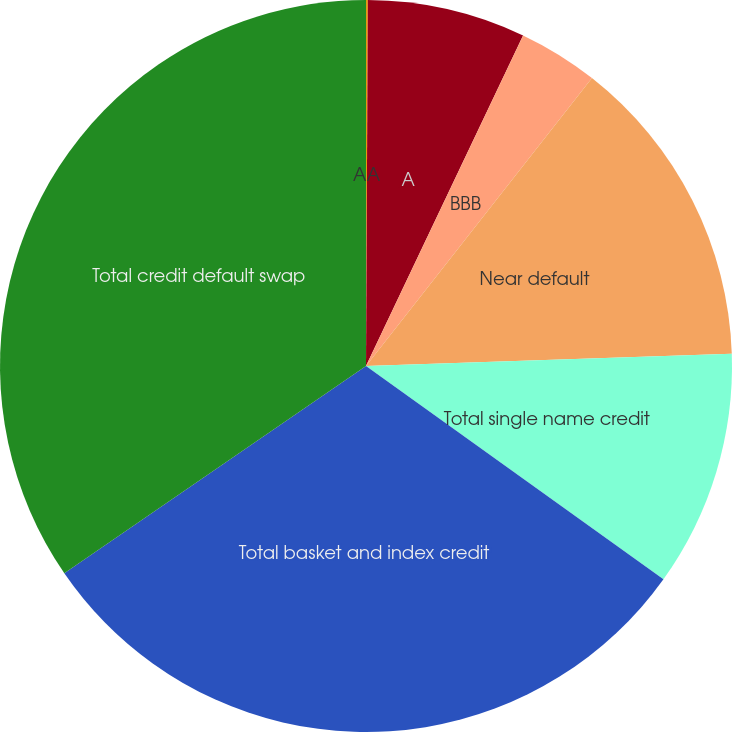Convert chart. <chart><loc_0><loc_0><loc_500><loc_500><pie_chart><fcel>AA<fcel>A<fcel>BBB<fcel>Near default<fcel>Total single name credit<fcel>Total basket and index credit<fcel>Total credit default swap<nl><fcel>0.08%<fcel>6.98%<fcel>3.53%<fcel>13.88%<fcel>10.43%<fcel>30.52%<fcel>34.58%<nl></chart> 